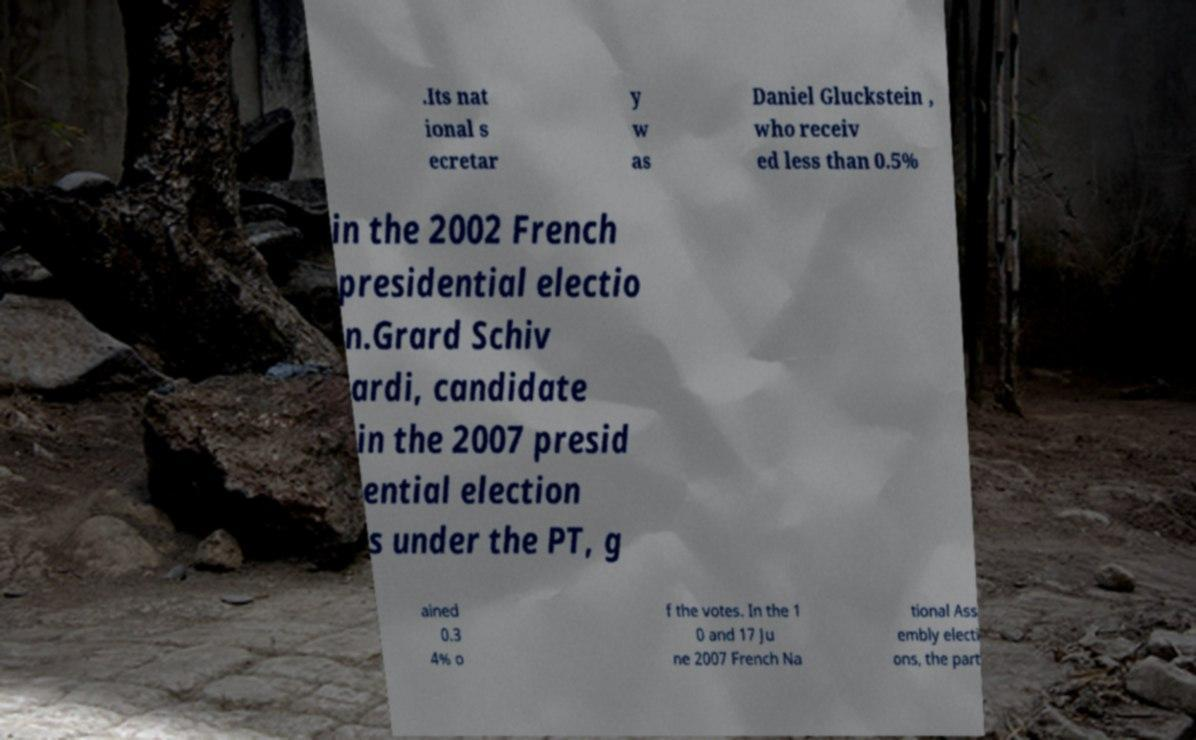Please identify and transcribe the text found in this image. .Its nat ional s ecretar y w as Daniel Gluckstein , who receiv ed less than 0.5% in the 2002 French presidential electio n.Grard Schiv ardi, candidate in the 2007 presid ential election s under the PT, g ained 0.3 4% o f the votes. In the 1 0 and 17 Ju ne 2007 French Na tional Ass embly electi ons, the part 